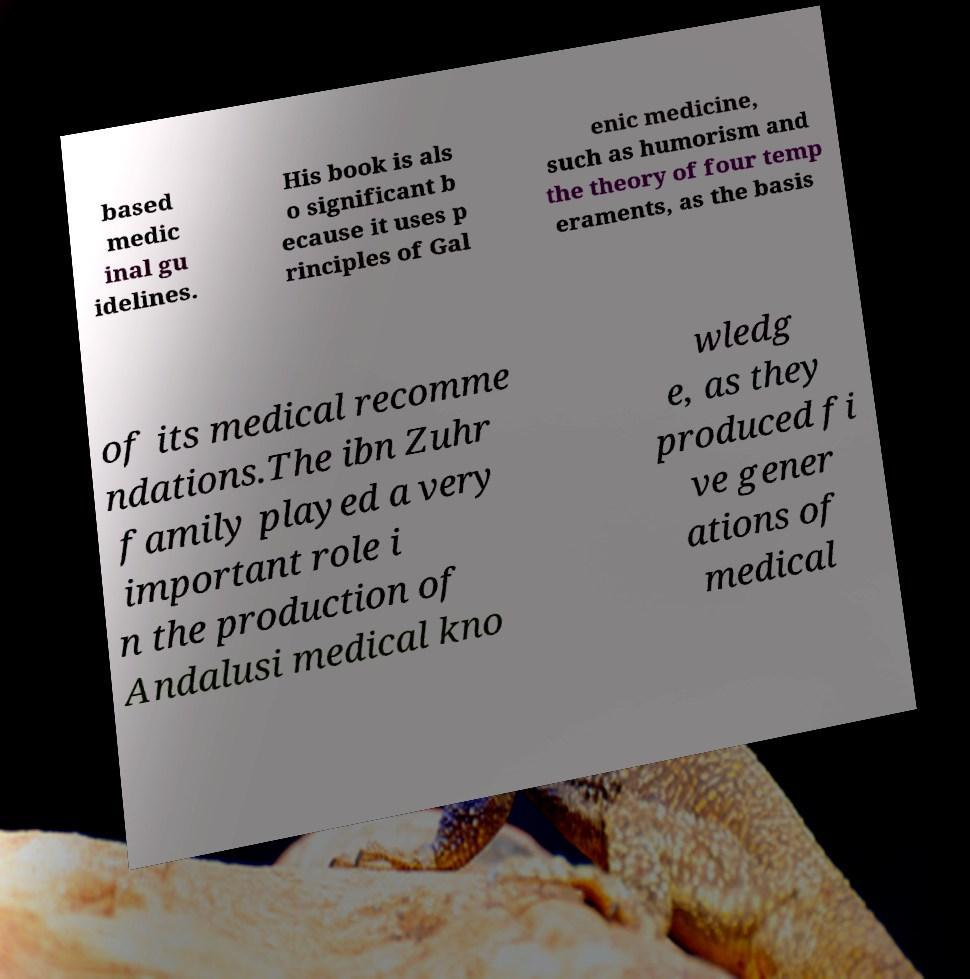Can you accurately transcribe the text from the provided image for me? based medic inal gu idelines. His book is als o significant b ecause it uses p rinciples of Gal enic medicine, such as humorism and the theory of four temp eraments, as the basis of its medical recomme ndations.The ibn Zuhr family played a very important role i n the production of Andalusi medical kno wledg e, as they produced fi ve gener ations of medical 